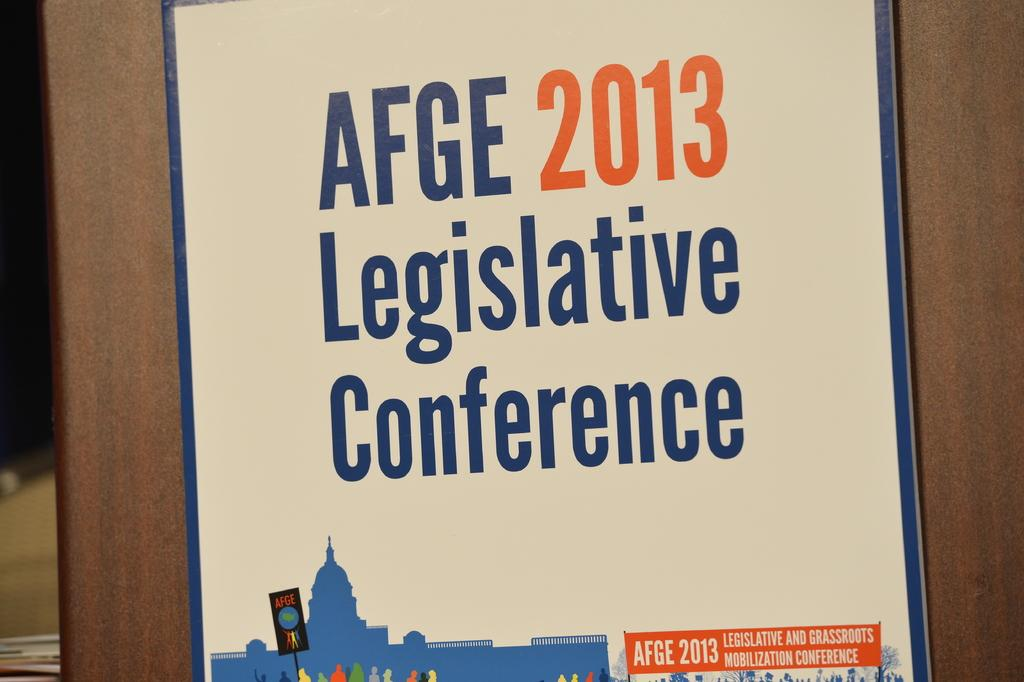<image>
Write a terse but informative summary of the picture. A sign for the AFGE legislative conference in 2013. 